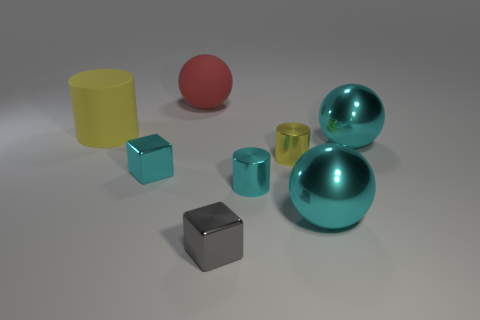There is a tiny gray shiny block; what number of cyan metal things are right of it?
Your answer should be compact. 3. Are there any large yellow cylinders made of the same material as the red thing?
Give a very brief answer. Yes. There is another cube that is the same size as the gray cube; what is its material?
Your answer should be compact. Metal. There is a thing that is both in front of the yellow rubber cylinder and on the left side of the matte sphere; how big is it?
Make the answer very short. Small. What color is the big ball that is behind the tiny cyan metallic cylinder and to the right of the large red matte object?
Give a very brief answer. Cyan. Is the number of gray things that are behind the yellow matte object less than the number of big cyan shiny objects that are in front of the small cyan metallic cylinder?
Offer a terse response. Yes. How many other large yellow matte things have the same shape as the large yellow rubber object?
Your response must be concise. 0. There is a red object that is the same material as the large yellow cylinder; what is its size?
Your response must be concise. Large. What is the color of the matte object that is on the left side of the shiny cube that is to the left of the large red rubber sphere?
Provide a short and direct response. Yellow. Is the shape of the large red thing the same as the cyan object that is behind the small cyan shiny block?
Your answer should be very brief. Yes. 